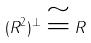Convert formula to latex. <formula><loc_0><loc_0><loc_500><loc_500>( R ^ { 2 } ) ^ { \perp } \cong R</formula> 